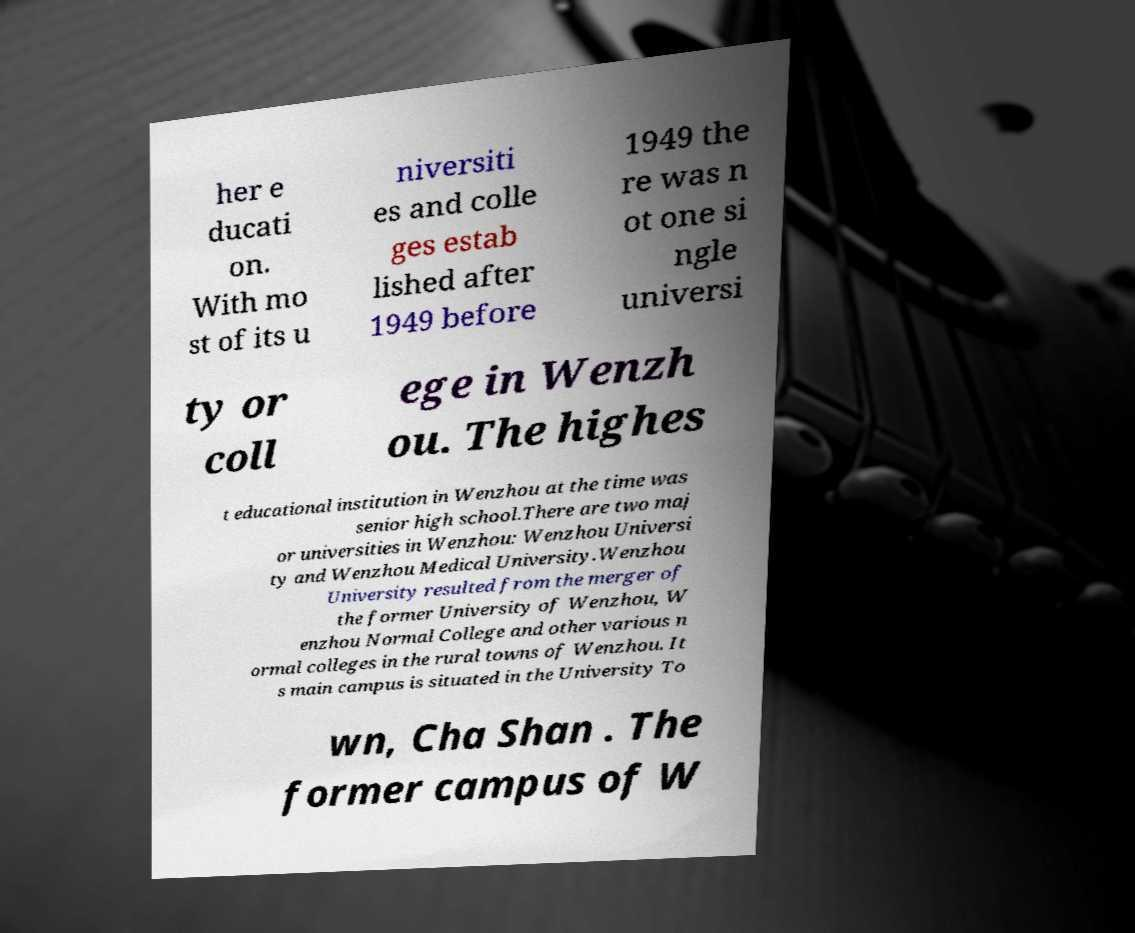Can you read and provide the text displayed in the image?This photo seems to have some interesting text. Can you extract and type it out for me? her e ducati on. With mo st of its u niversiti es and colle ges estab lished after 1949 before 1949 the re was n ot one si ngle universi ty or coll ege in Wenzh ou. The highes t educational institution in Wenzhou at the time was senior high school.There are two maj or universities in Wenzhou: Wenzhou Universi ty and Wenzhou Medical University.Wenzhou University resulted from the merger of the former University of Wenzhou, W enzhou Normal College and other various n ormal colleges in the rural towns of Wenzhou. It s main campus is situated in the University To wn, Cha Shan . The former campus of W 